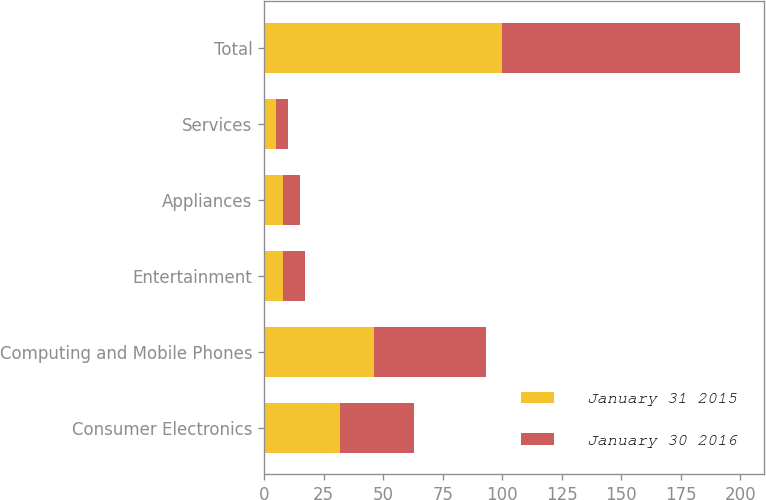Convert chart to OTSL. <chart><loc_0><loc_0><loc_500><loc_500><stacked_bar_chart><ecel><fcel>Consumer Electronics<fcel>Computing and Mobile Phones<fcel>Entertainment<fcel>Appliances<fcel>Services<fcel>Total<nl><fcel>January 31 2015<fcel>32<fcel>46<fcel>8<fcel>8<fcel>5<fcel>100<nl><fcel>January 30 2016<fcel>31<fcel>47<fcel>9<fcel>7<fcel>5<fcel>100<nl></chart> 